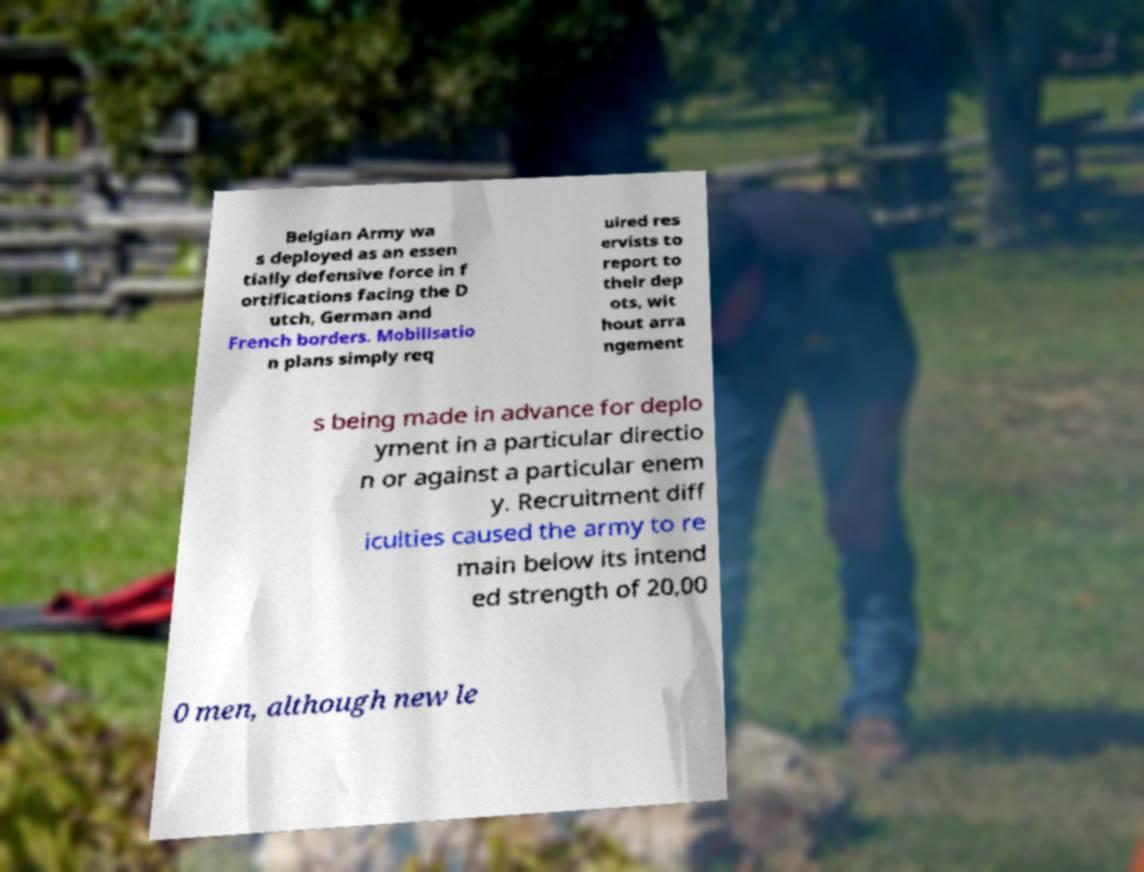I need the written content from this picture converted into text. Can you do that? Belgian Army wa s deployed as an essen tially defensive force in f ortifications facing the D utch, German and French borders. Mobilisatio n plans simply req uired res ervists to report to their dep ots, wit hout arra ngement s being made in advance for deplo yment in a particular directio n or against a particular enem y. Recruitment diff iculties caused the army to re main below its intend ed strength of 20,00 0 men, although new le 